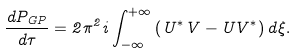Convert formula to latex. <formula><loc_0><loc_0><loc_500><loc_500>\frac { d P _ { G P } } { d \tau } = 2 \pi ^ { 2 } i \int _ { - \infty } ^ { + \infty } \left ( U ^ { \ast } V - U V ^ { \ast } \right ) d \xi .</formula> 